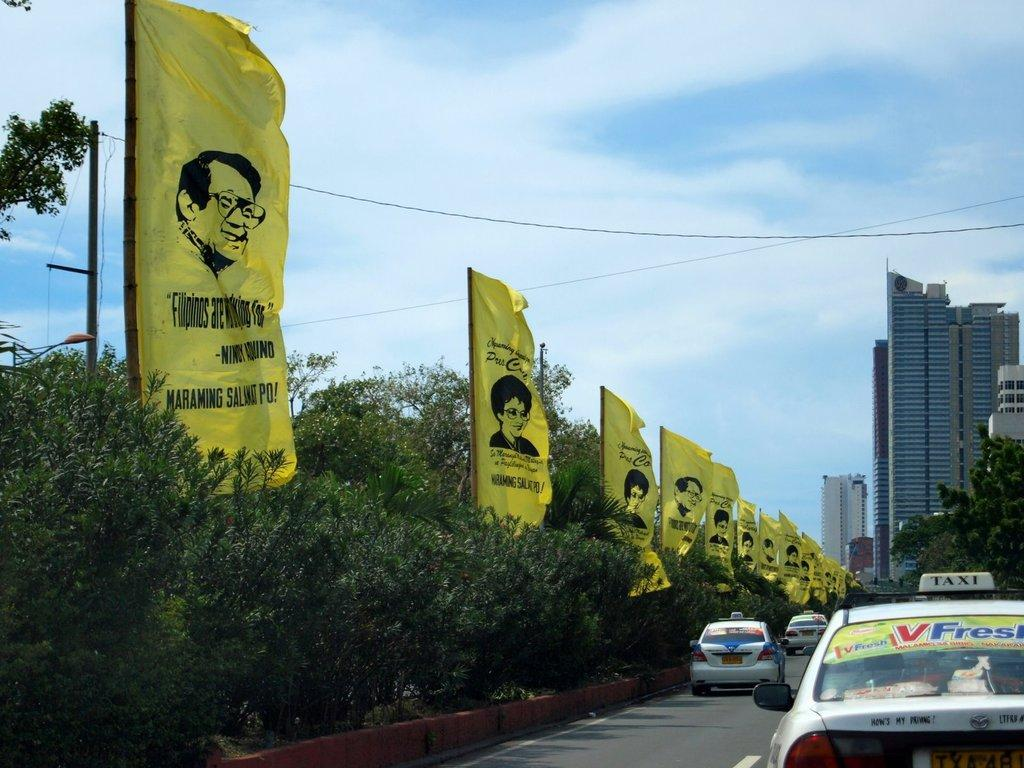<image>
Give a short and clear explanation of the subsequent image. A street lined with taxis on one side and Large yellow flags on the other that read, filipinos are working for Nicky Round. 